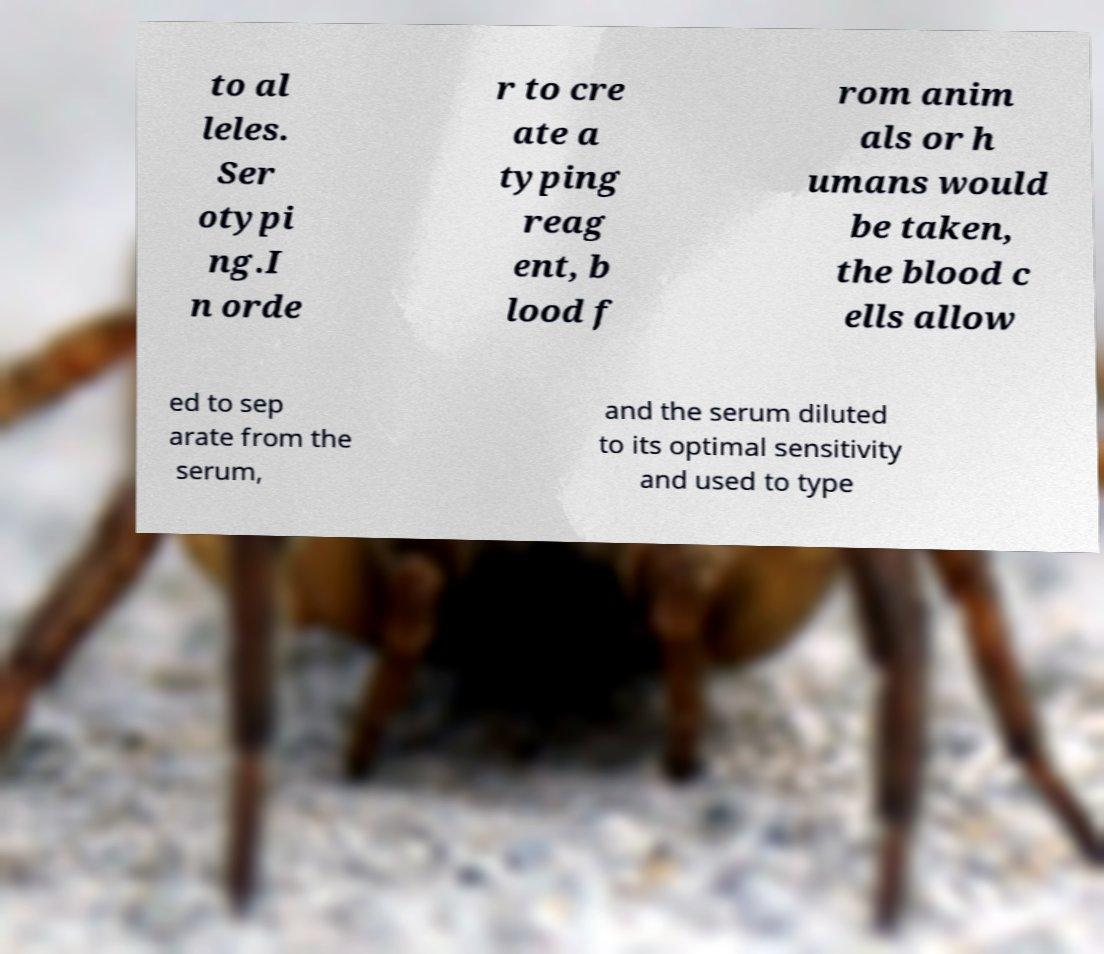Please read and relay the text visible in this image. What does it say? to al leles. Ser otypi ng.I n orde r to cre ate a typing reag ent, b lood f rom anim als or h umans would be taken, the blood c ells allow ed to sep arate from the serum, and the serum diluted to its optimal sensitivity and used to type 